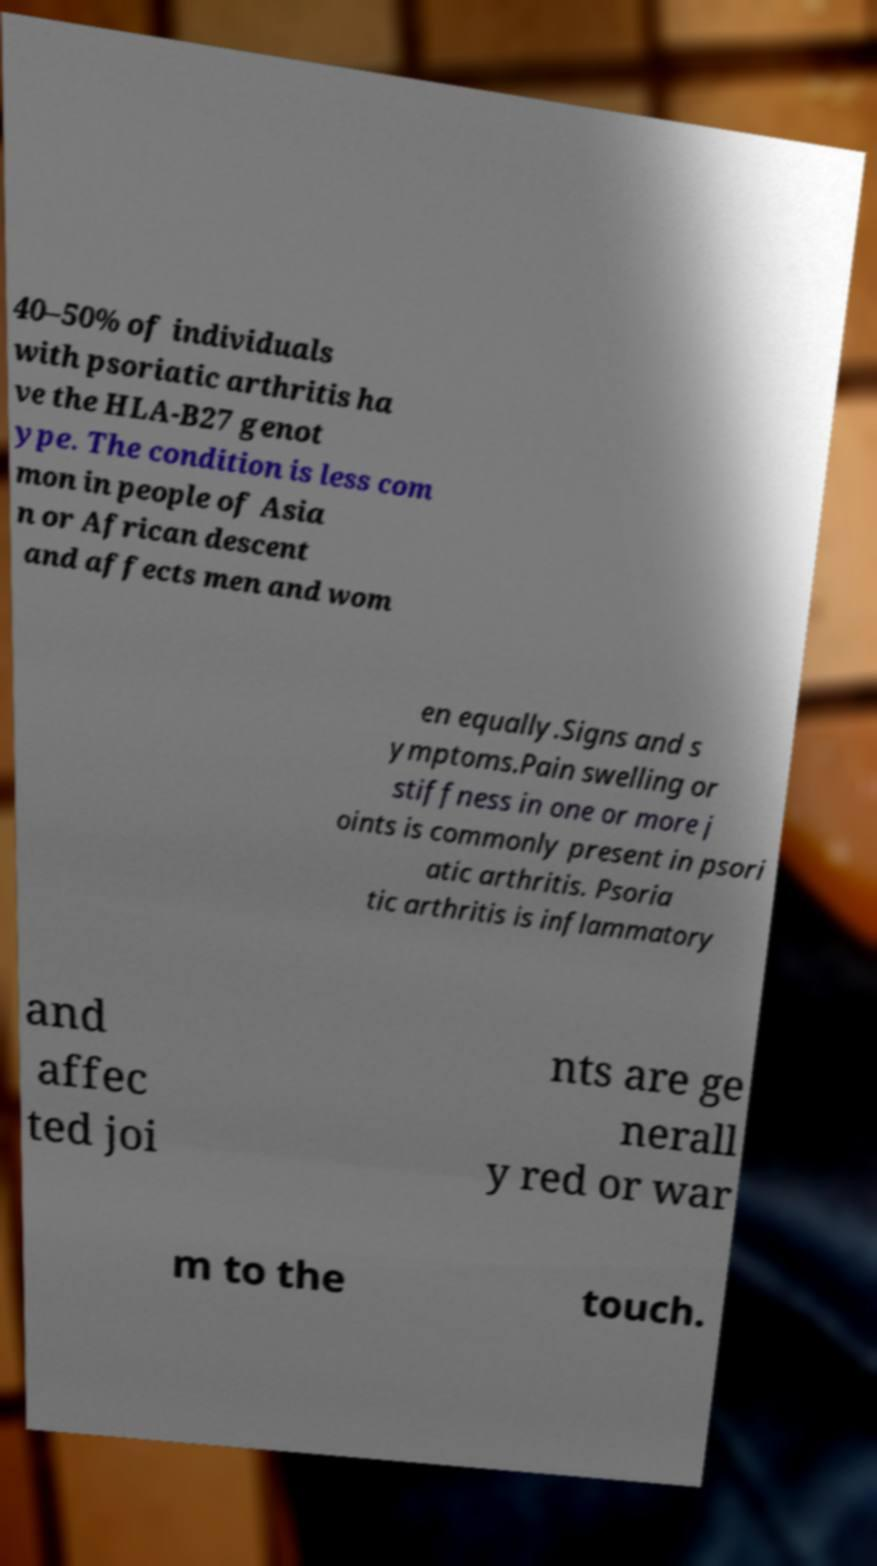There's text embedded in this image that I need extracted. Can you transcribe it verbatim? 40–50% of individuals with psoriatic arthritis ha ve the HLA-B27 genot ype. The condition is less com mon in people of Asia n or African descent and affects men and wom en equally.Signs and s ymptoms.Pain swelling or stiffness in one or more j oints is commonly present in psori atic arthritis. Psoria tic arthritis is inflammatory and affec ted joi nts are ge nerall y red or war m to the touch. 